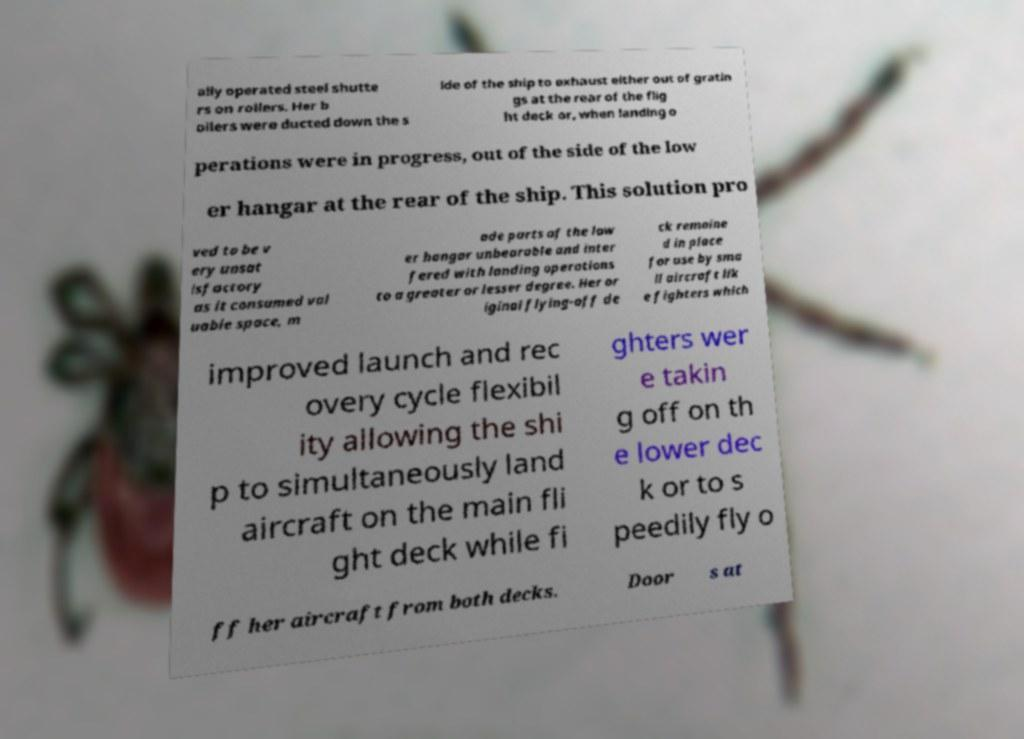Could you extract and type out the text from this image? ally operated steel shutte rs on rollers. Her b oilers were ducted down the s ide of the ship to exhaust either out of gratin gs at the rear of the flig ht deck or, when landing o perations were in progress, out of the side of the low er hangar at the rear of the ship. This solution pro ved to be v ery unsat isfactory as it consumed val uable space, m ade parts of the low er hangar unbearable and inter fered with landing operations to a greater or lesser degree. Her or iginal flying-off de ck remaine d in place for use by sma ll aircraft lik e fighters which improved launch and rec overy cycle flexibil ity allowing the shi p to simultaneously land aircraft on the main fli ght deck while fi ghters wer e takin g off on th e lower dec k or to s peedily fly o ff her aircraft from both decks. Door s at 